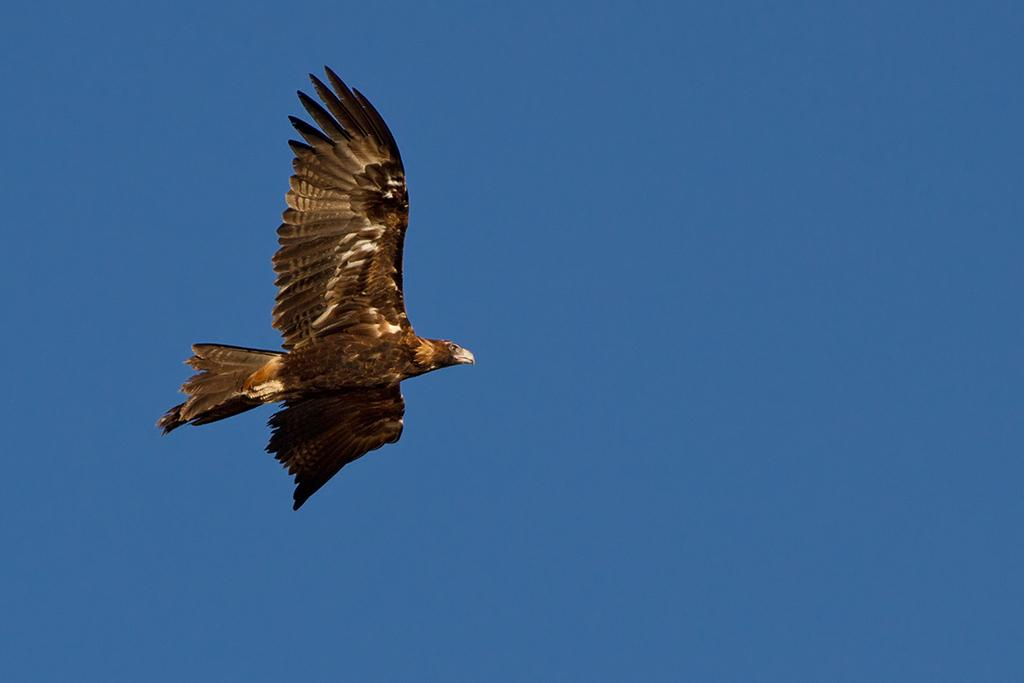What animal is present in the image? There is an eagle in the image. What is the eagle doing in the image? The eagle is flying in the air. What can be seen in the background of the image? The sky is visible in the image. What is the father's opinion about the eagle in the image? There is no information about a father or their opinion in the image. 